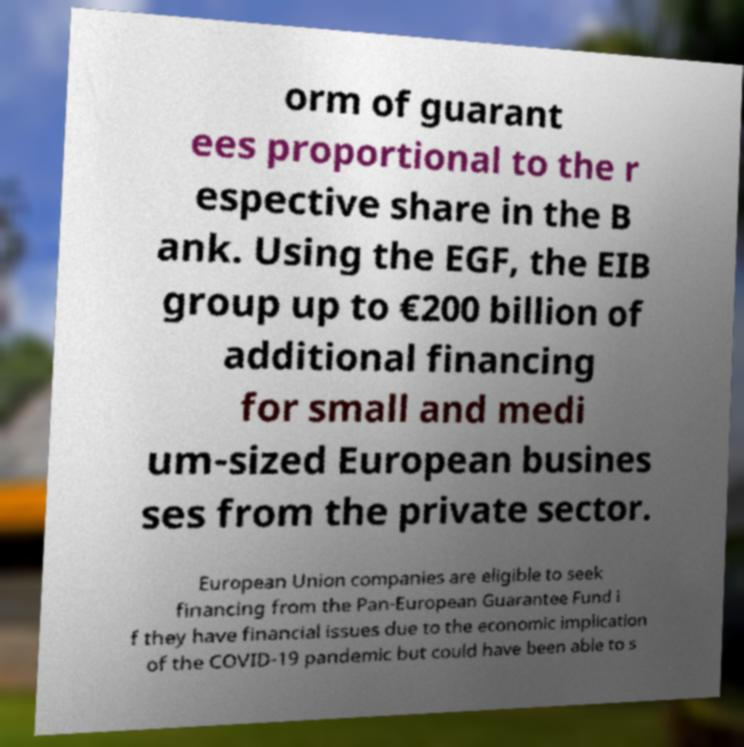Please read and relay the text visible in this image. What does it say? orm of guarant ees proportional to the r espective share in the B ank. Using the EGF, the EIB group up to €200 billion of additional financing for small and medi um-sized European busines ses from the private sector. European Union companies are eligible to seek financing from the Pan-European Guarantee Fund i f they have financial issues due to the economic implication of the COVID-19 pandemic but could have been able to s 